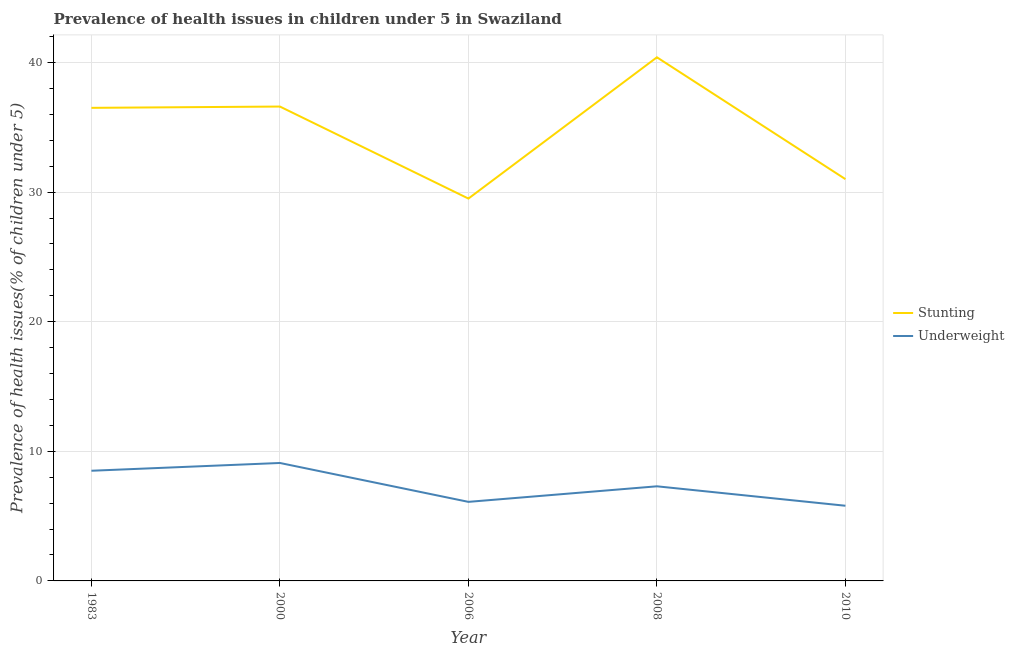How many different coloured lines are there?
Keep it short and to the point. 2. What is the percentage of stunted children in 2006?
Provide a succinct answer. 29.5. Across all years, what is the maximum percentage of stunted children?
Offer a very short reply. 40.4. Across all years, what is the minimum percentage of underweight children?
Ensure brevity in your answer.  5.8. What is the total percentage of underweight children in the graph?
Offer a terse response. 36.8. What is the difference between the percentage of stunted children in 1983 and that in 2000?
Keep it short and to the point. -0.1. What is the difference between the percentage of underweight children in 2006 and the percentage of stunted children in 1983?
Offer a terse response. -30.4. What is the average percentage of underweight children per year?
Ensure brevity in your answer.  7.36. In the year 2010, what is the difference between the percentage of stunted children and percentage of underweight children?
Your response must be concise. 25.2. In how many years, is the percentage of stunted children greater than 2 %?
Offer a terse response. 5. What is the ratio of the percentage of stunted children in 1983 to that in 2006?
Provide a succinct answer. 1.24. Is the percentage of stunted children in 2000 less than that in 2006?
Offer a very short reply. No. Is the difference between the percentage of stunted children in 2008 and 2010 greater than the difference between the percentage of underweight children in 2008 and 2010?
Your answer should be very brief. Yes. What is the difference between the highest and the second highest percentage of stunted children?
Your answer should be compact. 3.8. What is the difference between the highest and the lowest percentage of underweight children?
Provide a succinct answer. 3.3. In how many years, is the percentage of stunted children greater than the average percentage of stunted children taken over all years?
Your answer should be very brief. 3. Is the sum of the percentage of stunted children in 2006 and 2008 greater than the maximum percentage of underweight children across all years?
Offer a terse response. Yes. Does the percentage of stunted children monotonically increase over the years?
Your response must be concise. No. Is the percentage of stunted children strictly less than the percentage of underweight children over the years?
Your response must be concise. No. How many lines are there?
Offer a terse response. 2. What is the difference between two consecutive major ticks on the Y-axis?
Make the answer very short. 10. Are the values on the major ticks of Y-axis written in scientific E-notation?
Provide a short and direct response. No. Does the graph contain any zero values?
Ensure brevity in your answer.  No. Does the graph contain grids?
Offer a very short reply. Yes. How many legend labels are there?
Provide a short and direct response. 2. How are the legend labels stacked?
Provide a succinct answer. Vertical. What is the title of the graph?
Offer a very short reply. Prevalence of health issues in children under 5 in Swaziland. What is the label or title of the Y-axis?
Give a very brief answer. Prevalence of health issues(% of children under 5). What is the Prevalence of health issues(% of children under 5) of Stunting in 1983?
Offer a terse response. 36.5. What is the Prevalence of health issues(% of children under 5) of Underweight in 1983?
Keep it short and to the point. 8.5. What is the Prevalence of health issues(% of children under 5) of Stunting in 2000?
Provide a succinct answer. 36.6. What is the Prevalence of health issues(% of children under 5) in Underweight in 2000?
Offer a very short reply. 9.1. What is the Prevalence of health issues(% of children under 5) of Stunting in 2006?
Offer a very short reply. 29.5. What is the Prevalence of health issues(% of children under 5) in Underweight in 2006?
Your answer should be compact. 6.1. What is the Prevalence of health issues(% of children under 5) in Stunting in 2008?
Offer a very short reply. 40.4. What is the Prevalence of health issues(% of children under 5) of Underweight in 2008?
Ensure brevity in your answer.  7.3. What is the Prevalence of health issues(% of children under 5) in Stunting in 2010?
Offer a very short reply. 31. What is the Prevalence of health issues(% of children under 5) in Underweight in 2010?
Provide a short and direct response. 5.8. Across all years, what is the maximum Prevalence of health issues(% of children under 5) in Stunting?
Your answer should be very brief. 40.4. Across all years, what is the maximum Prevalence of health issues(% of children under 5) of Underweight?
Provide a short and direct response. 9.1. Across all years, what is the minimum Prevalence of health issues(% of children under 5) of Stunting?
Provide a succinct answer. 29.5. Across all years, what is the minimum Prevalence of health issues(% of children under 5) of Underweight?
Your response must be concise. 5.8. What is the total Prevalence of health issues(% of children under 5) of Stunting in the graph?
Offer a terse response. 174. What is the total Prevalence of health issues(% of children under 5) of Underweight in the graph?
Ensure brevity in your answer.  36.8. What is the difference between the Prevalence of health issues(% of children under 5) of Stunting in 1983 and that in 2008?
Provide a succinct answer. -3.9. What is the difference between the Prevalence of health issues(% of children under 5) of Underweight in 1983 and that in 2008?
Provide a succinct answer. 1.2. What is the difference between the Prevalence of health issues(% of children under 5) in Stunting in 2000 and that in 2006?
Your answer should be compact. 7.1. What is the difference between the Prevalence of health issues(% of children under 5) in Underweight in 2000 and that in 2006?
Make the answer very short. 3. What is the difference between the Prevalence of health issues(% of children under 5) in Stunting in 2000 and that in 2008?
Offer a terse response. -3.8. What is the difference between the Prevalence of health issues(% of children under 5) in Underweight in 2000 and that in 2010?
Your answer should be compact. 3.3. What is the difference between the Prevalence of health issues(% of children under 5) of Underweight in 2006 and that in 2008?
Provide a short and direct response. -1.2. What is the difference between the Prevalence of health issues(% of children under 5) in Stunting in 2006 and that in 2010?
Make the answer very short. -1.5. What is the difference between the Prevalence of health issues(% of children under 5) of Underweight in 2006 and that in 2010?
Your answer should be compact. 0.3. What is the difference between the Prevalence of health issues(% of children under 5) of Stunting in 2008 and that in 2010?
Provide a short and direct response. 9.4. What is the difference between the Prevalence of health issues(% of children under 5) of Stunting in 1983 and the Prevalence of health issues(% of children under 5) of Underweight in 2000?
Your answer should be compact. 27.4. What is the difference between the Prevalence of health issues(% of children under 5) in Stunting in 1983 and the Prevalence of health issues(% of children under 5) in Underweight in 2006?
Keep it short and to the point. 30.4. What is the difference between the Prevalence of health issues(% of children under 5) of Stunting in 1983 and the Prevalence of health issues(% of children under 5) of Underweight in 2008?
Provide a short and direct response. 29.2. What is the difference between the Prevalence of health issues(% of children under 5) of Stunting in 1983 and the Prevalence of health issues(% of children under 5) of Underweight in 2010?
Your answer should be compact. 30.7. What is the difference between the Prevalence of health issues(% of children under 5) of Stunting in 2000 and the Prevalence of health issues(% of children under 5) of Underweight in 2006?
Provide a short and direct response. 30.5. What is the difference between the Prevalence of health issues(% of children under 5) of Stunting in 2000 and the Prevalence of health issues(% of children under 5) of Underweight in 2008?
Your response must be concise. 29.3. What is the difference between the Prevalence of health issues(% of children under 5) of Stunting in 2000 and the Prevalence of health issues(% of children under 5) of Underweight in 2010?
Make the answer very short. 30.8. What is the difference between the Prevalence of health issues(% of children under 5) of Stunting in 2006 and the Prevalence of health issues(% of children under 5) of Underweight in 2010?
Provide a short and direct response. 23.7. What is the difference between the Prevalence of health issues(% of children under 5) in Stunting in 2008 and the Prevalence of health issues(% of children under 5) in Underweight in 2010?
Provide a short and direct response. 34.6. What is the average Prevalence of health issues(% of children under 5) of Stunting per year?
Provide a short and direct response. 34.8. What is the average Prevalence of health issues(% of children under 5) in Underweight per year?
Your answer should be compact. 7.36. In the year 1983, what is the difference between the Prevalence of health issues(% of children under 5) in Stunting and Prevalence of health issues(% of children under 5) in Underweight?
Provide a succinct answer. 28. In the year 2000, what is the difference between the Prevalence of health issues(% of children under 5) of Stunting and Prevalence of health issues(% of children under 5) of Underweight?
Make the answer very short. 27.5. In the year 2006, what is the difference between the Prevalence of health issues(% of children under 5) of Stunting and Prevalence of health issues(% of children under 5) of Underweight?
Your response must be concise. 23.4. In the year 2008, what is the difference between the Prevalence of health issues(% of children under 5) in Stunting and Prevalence of health issues(% of children under 5) in Underweight?
Provide a succinct answer. 33.1. In the year 2010, what is the difference between the Prevalence of health issues(% of children under 5) in Stunting and Prevalence of health issues(% of children under 5) in Underweight?
Your answer should be compact. 25.2. What is the ratio of the Prevalence of health issues(% of children under 5) in Stunting in 1983 to that in 2000?
Give a very brief answer. 1. What is the ratio of the Prevalence of health issues(% of children under 5) of Underweight in 1983 to that in 2000?
Provide a short and direct response. 0.93. What is the ratio of the Prevalence of health issues(% of children under 5) of Stunting in 1983 to that in 2006?
Provide a succinct answer. 1.24. What is the ratio of the Prevalence of health issues(% of children under 5) of Underweight in 1983 to that in 2006?
Your answer should be very brief. 1.39. What is the ratio of the Prevalence of health issues(% of children under 5) of Stunting in 1983 to that in 2008?
Your answer should be compact. 0.9. What is the ratio of the Prevalence of health issues(% of children under 5) in Underweight in 1983 to that in 2008?
Ensure brevity in your answer.  1.16. What is the ratio of the Prevalence of health issues(% of children under 5) in Stunting in 1983 to that in 2010?
Provide a succinct answer. 1.18. What is the ratio of the Prevalence of health issues(% of children under 5) of Underweight in 1983 to that in 2010?
Give a very brief answer. 1.47. What is the ratio of the Prevalence of health issues(% of children under 5) of Stunting in 2000 to that in 2006?
Your response must be concise. 1.24. What is the ratio of the Prevalence of health issues(% of children under 5) in Underweight in 2000 to that in 2006?
Make the answer very short. 1.49. What is the ratio of the Prevalence of health issues(% of children under 5) in Stunting in 2000 to that in 2008?
Your response must be concise. 0.91. What is the ratio of the Prevalence of health issues(% of children under 5) in Underweight in 2000 to that in 2008?
Provide a succinct answer. 1.25. What is the ratio of the Prevalence of health issues(% of children under 5) in Stunting in 2000 to that in 2010?
Your answer should be compact. 1.18. What is the ratio of the Prevalence of health issues(% of children under 5) in Underweight in 2000 to that in 2010?
Provide a succinct answer. 1.57. What is the ratio of the Prevalence of health issues(% of children under 5) of Stunting in 2006 to that in 2008?
Give a very brief answer. 0.73. What is the ratio of the Prevalence of health issues(% of children under 5) in Underweight in 2006 to that in 2008?
Offer a very short reply. 0.84. What is the ratio of the Prevalence of health issues(% of children under 5) of Stunting in 2006 to that in 2010?
Your response must be concise. 0.95. What is the ratio of the Prevalence of health issues(% of children under 5) of Underweight in 2006 to that in 2010?
Your answer should be very brief. 1.05. What is the ratio of the Prevalence of health issues(% of children under 5) of Stunting in 2008 to that in 2010?
Provide a short and direct response. 1.3. What is the ratio of the Prevalence of health issues(% of children under 5) in Underweight in 2008 to that in 2010?
Give a very brief answer. 1.26. What is the difference between the highest and the second highest Prevalence of health issues(% of children under 5) of Stunting?
Make the answer very short. 3.8. What is the difference between the highest and the second highest Prevalence of health issues(% of children under 5) in Underweight?
Provide a succinct answer. 0.6. What is the difference between the highest and the lowest Prevalence of health issues(% of children under 5) in Stunting?
Offer a very short reply. 10.9. 